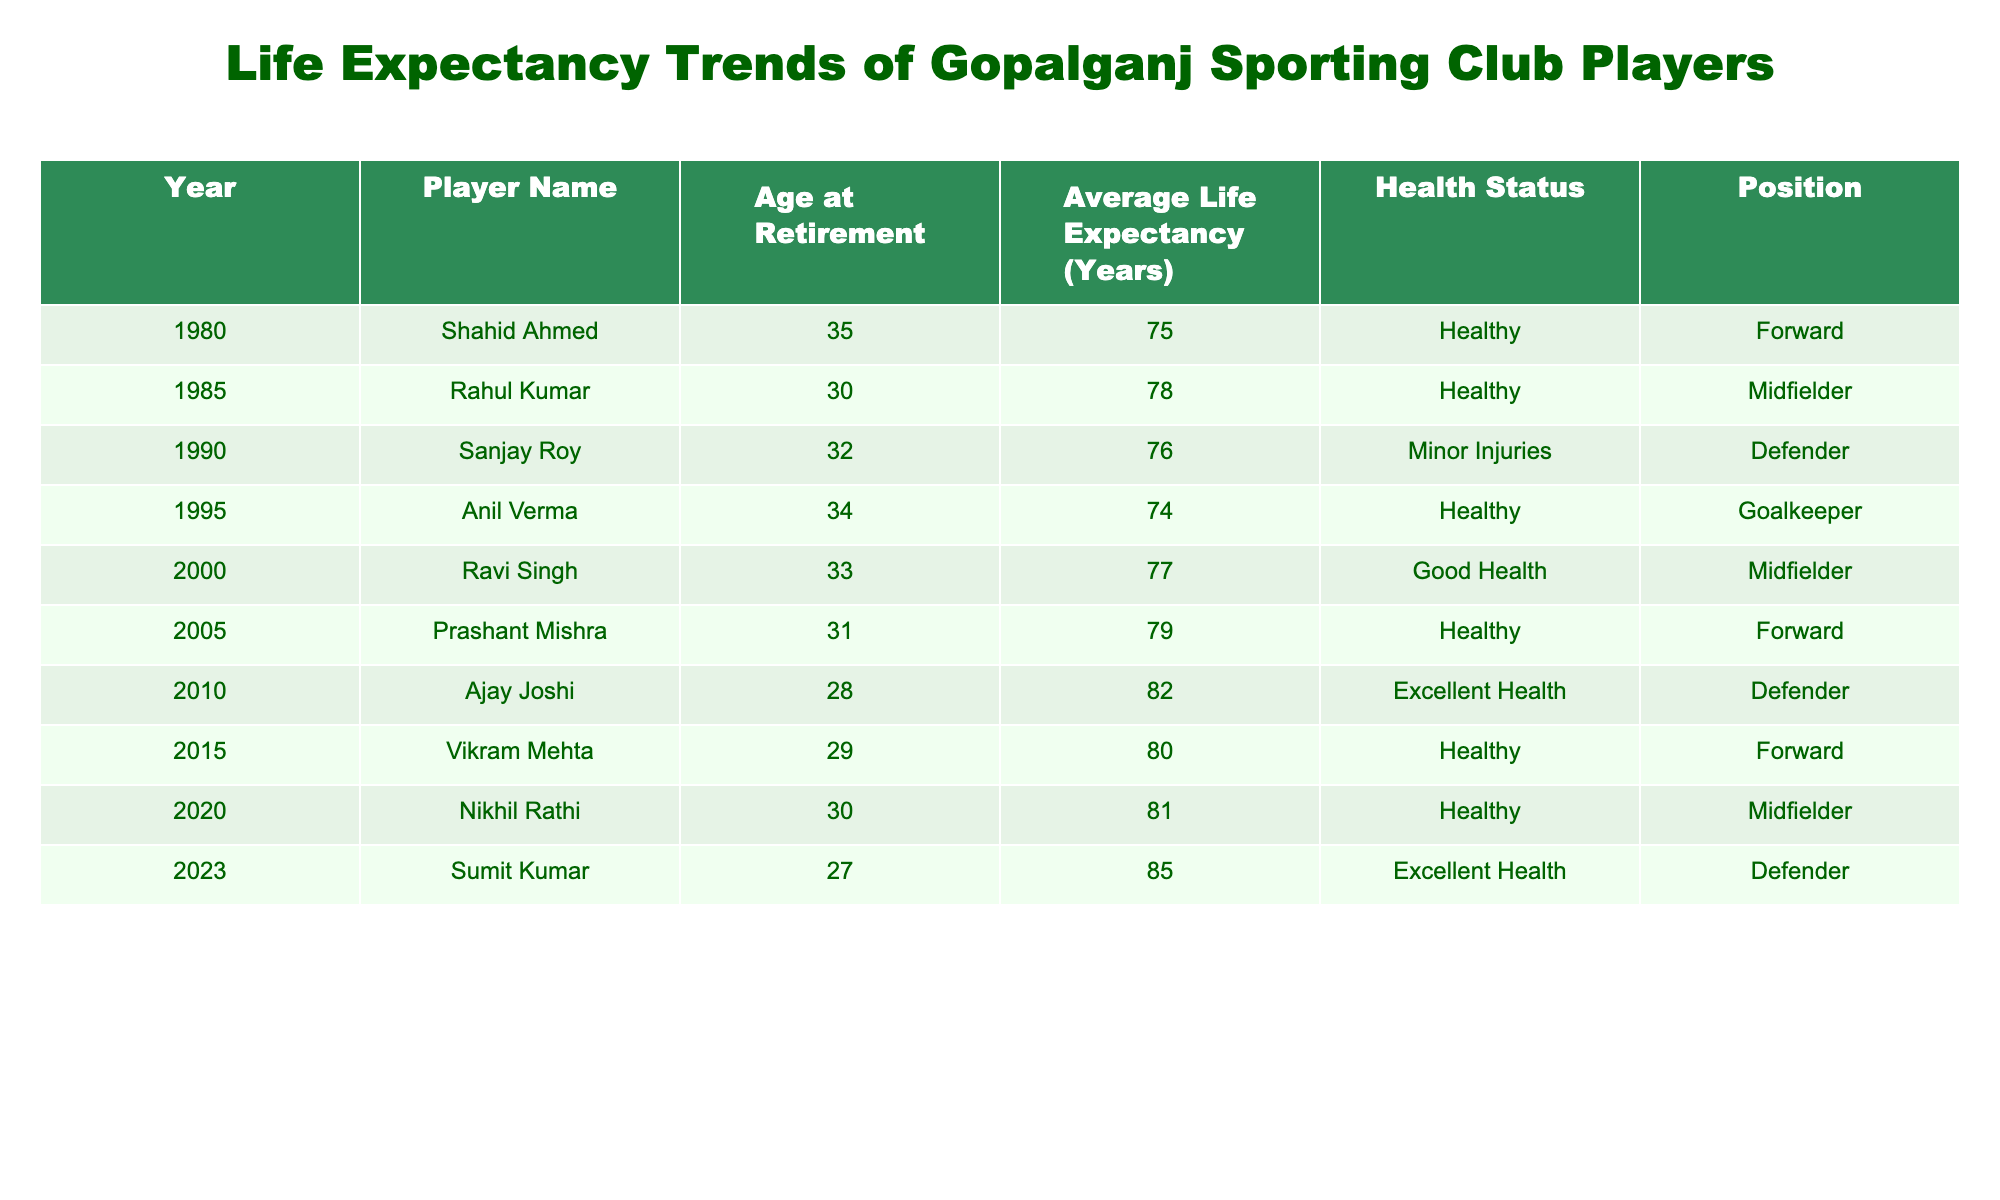What was the average life expectancy of players in the year 2000? The life expectancy for the player Ravi Singh, who retired in 2000, is listed as 77 years. Therefore, the average life expectancy for players in that year is 77.
Answer: 77 Which player had the longest average life expectancy in the data provided? The player with the longest average life expectancy is Sumit Kumar from 2023, with an average life expectancy of 85 years.
Answer: 85 Did any player retire with a status of "Excellent Health"? Yes, both Ajay Joshi (2010) and Sumit Kumar (2023) retired with a health status of "Excellent Health."
Answer: Yes What is the difference in average life expectancy between players who retired in 1985 and 2015? The average life expectancy for Rahul Kumar in 1985 is 78 years, and for Vikram Mehta in 2015, it is 80 years. The difference is 80 - 78 = 2 years.
Answer: 2 What is the trend in average life expectancy from 1980 to 2023? To determine the trend, we look at the life expectancy values over the years: 75 (1980), 78 (1985), 76 (1990), 74 (1995), 77 (2000), 79 (2005), 82 (2010), 80 (2015), 81 (2020), and 85 (2023). The values show an overall increase from 75 to 85 years.
Answer: Increasing How many players had a health status classified as "Healthy"? Reviewing the health status column, we find that Shahid Ahmed, Rahul Kumar, Prashant Mishra, Vikram Mehta, and Nikhil Rathi all had the status of "Healthy." Thus, there are 5 players classified as "Healthy."
Answer: 5 Which decade had the highest average life expectancy based on the players' retirement years? The average life expectancy across decades is: 1980s (76.5), 1990s (75), 2000s (78), 2010s (81), and 2020s (85). The highest average is in the 2020s with 85 years.
Answer: 2020s Is there any player who retired as a Defender and had a life expectancy below 75 years? According to the table, Sanjay Roy, who retired in 1990 as a Defender, had an average life expectancy of 76 years. No defender retired with an expectancy below 75 years.
Answer: No 